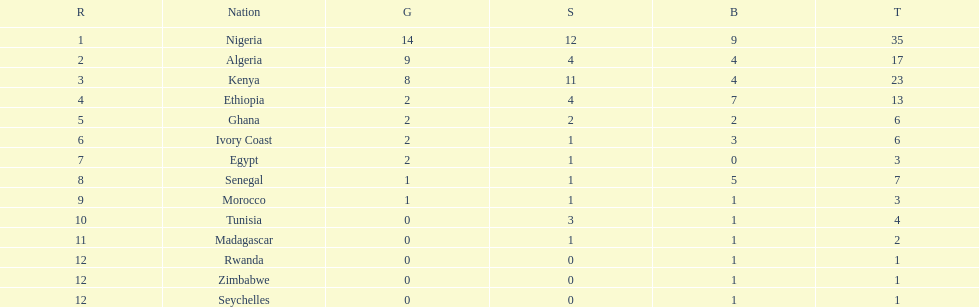What is the name of the only nation that did not earn any bronze medals? Egypt. 